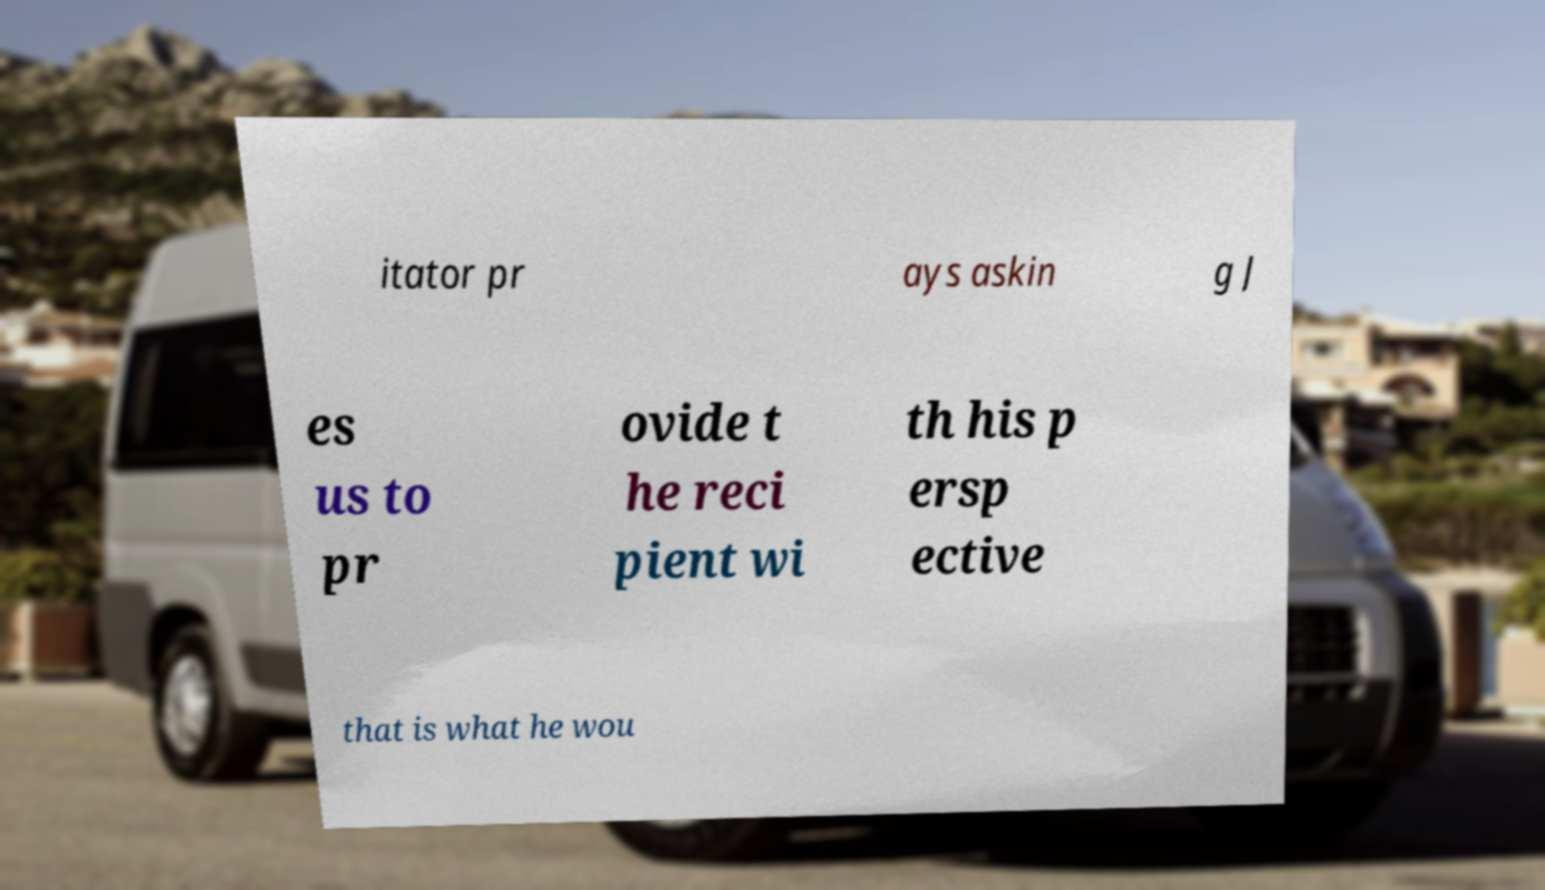Please identify and transcribe the text found in this image. itator pr ays askin g J es us to pr ovide t he reci pient wi th his p ersp ective that is what he wou 